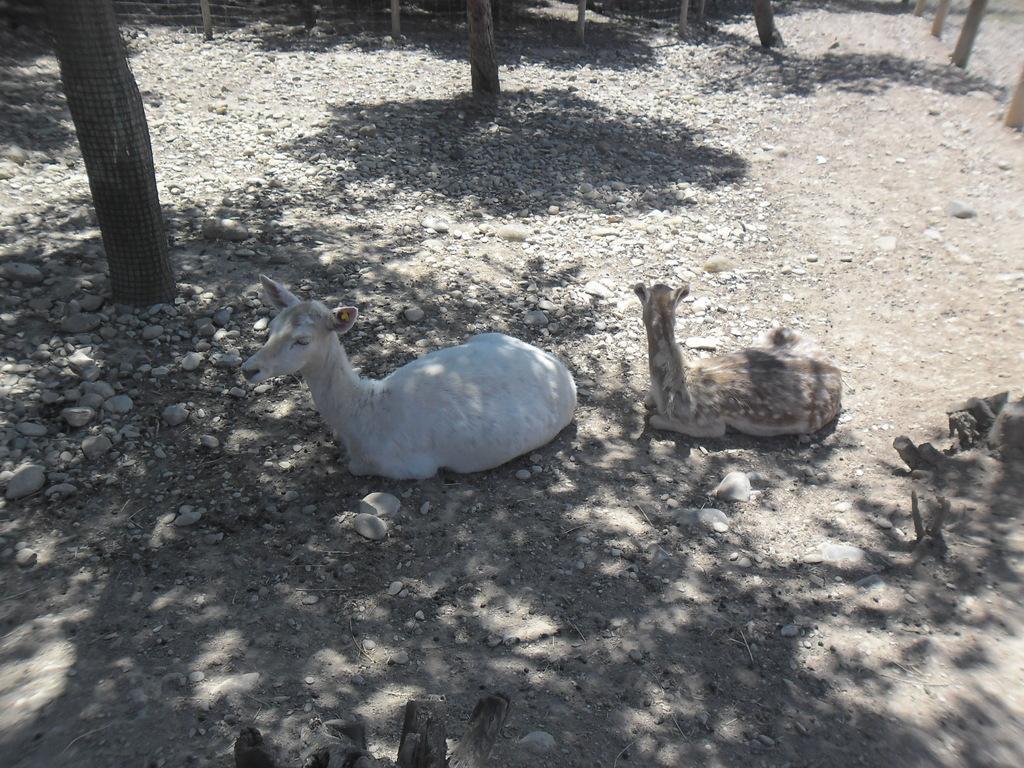Could you give a brief overview of what you see in this image? In this image I see the ground on which there are stones and I see the trees and I see 2 animals over here in which this one is of white in color and this one is of brown and cream in color. 